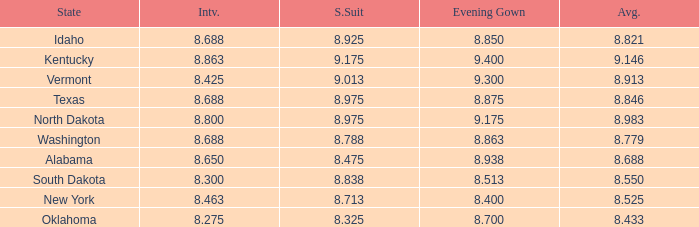What is the lowest average of the contestant with an interview of 8.275 and an evening gown bigger than 8.7? None. 